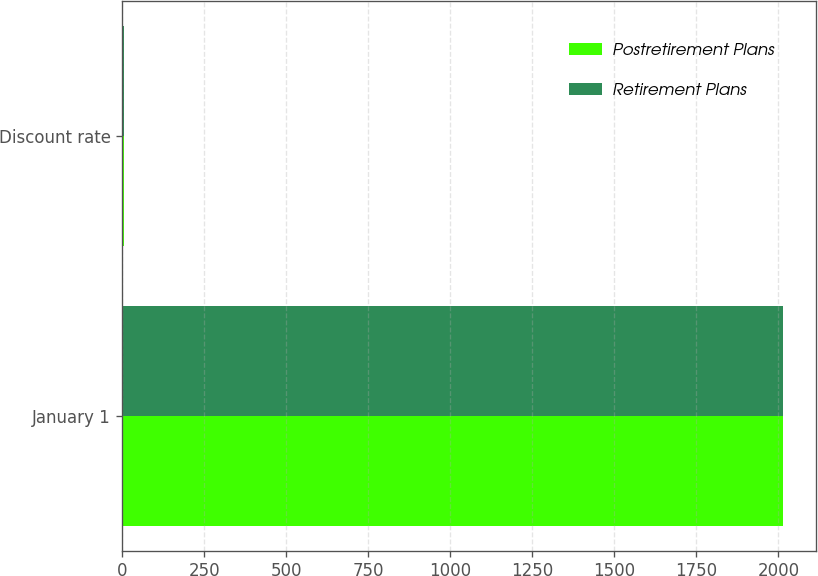Convert chart to OTSL. <chart><loc_0><loc_0><loc_500><loc_500><stacked_bar_chart><ecel><fcel>January 1<fcel>Discount rate<nl><fcel>Postretirement Plans<fcel>2013<fcel>4.1<nl><fcel>Retirement Plans<fcel>2013<fcel>3.45<nl></chart> 